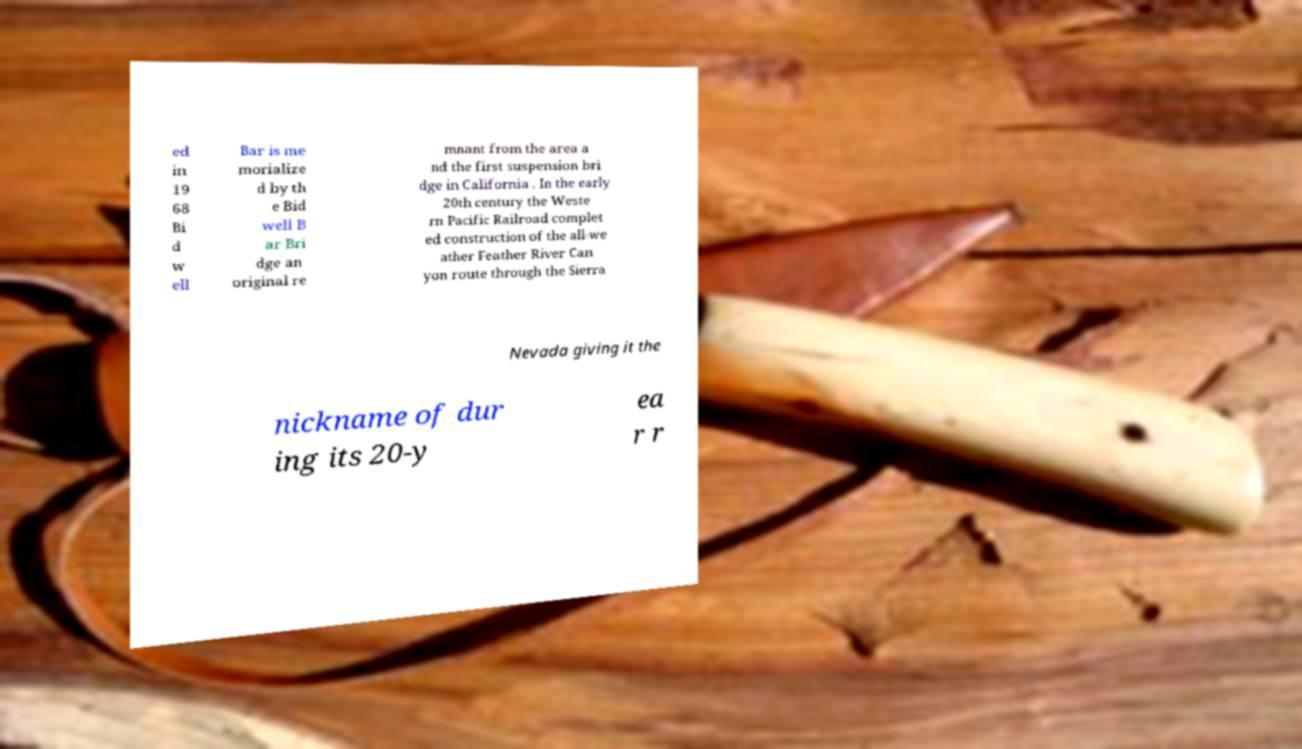Please read and relay the text visible in this image. What does it say? ed in 19 68 Bi d w ell Bar is me morialize d by th e Bid well B ar Bri dge an original re mnant from the area a nd the first suspension bri dge in California . In the early 20th century the Weste rn Pacific Railroad complet ed construction of the all-we ather Feather River Can yon route through the Sierra Nevada giving it the nickname of dur ing its 20-y ea r r 